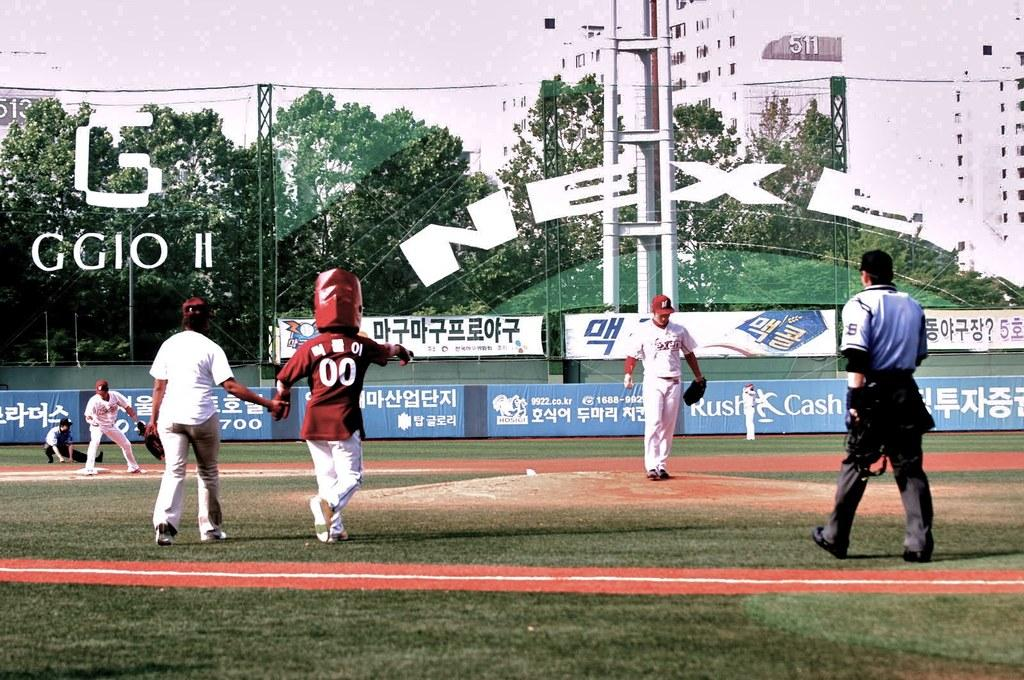<image>
Write a terse but informative summary of the picture. A Korean baseball field has a blue advertisement for Rush Cash. 